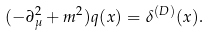<formula> <loc_0><loc_0><loc_500><loc_500>( - \partial _ { \mu } ^ { 2 } + m ^ { 2 } ) q ( x ) = \delta ^ { ( D ) } ( x ) .</formula> 